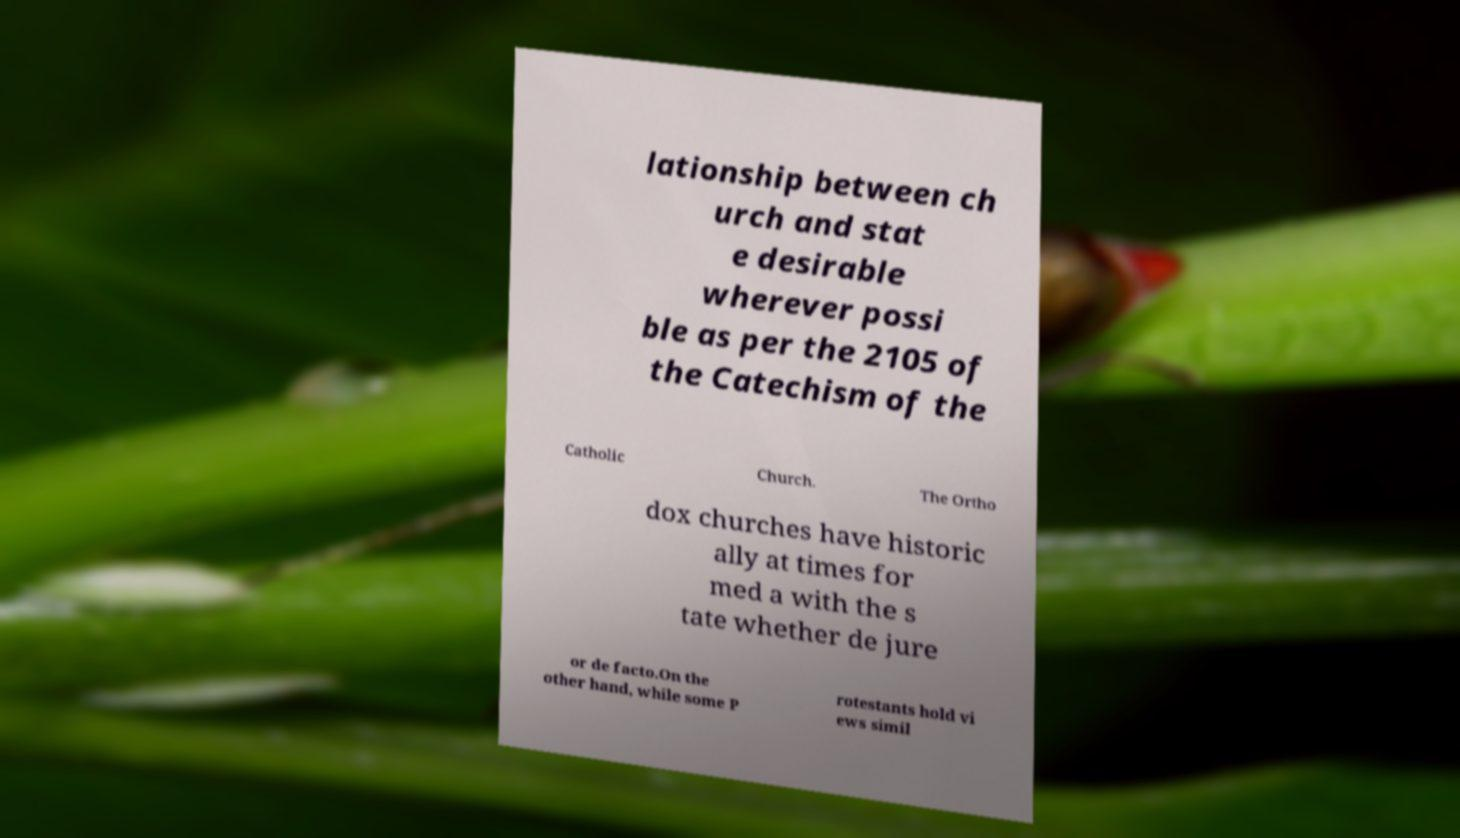There's text embedded in this image that I need extracted. Can you transcribe it verbatim? lationship between ch urch and stat e desirable wherever possi ble as per the 2105 of the Catechism of the Catholic Church. The Ortho dox churches have historic ally at times for med a with the s tate whether de jure or de facto.On the other hand, while some P rotestants hold vi ews simil 